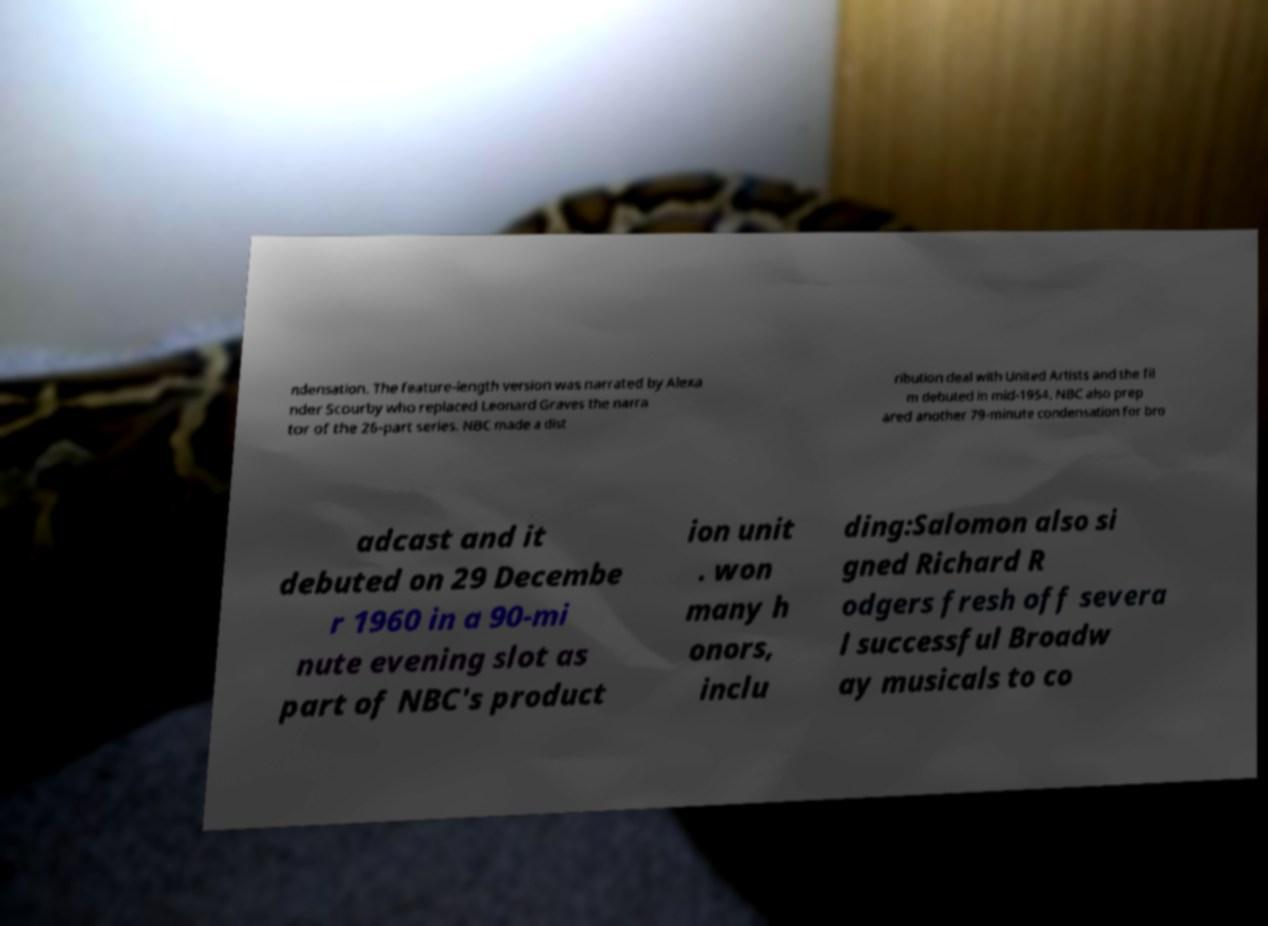What messages or text are displayed in this image? I need them in a readable, typed format. ndensation. The feature-length version was narrated by Alexa nder Scourby who replaced Leonard Graves the narra tor of the 26-part series. NBC made a dist ribution deal with United Artists and the fil m debuted in mid-1954. NBC also prep ared another 79-minute condensation for bro adcast and it debuted on 29 Decembe r 1960 in a 90-mi nute evening slot as part of NBC's product ion unit . won many h onors, inclu ding:Salomon also si gned Richard R odgers fresh off severa l successful Broadw ay musicals to co 